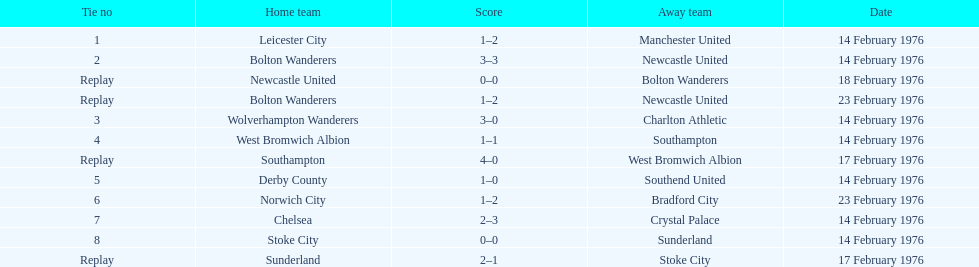How do southampton's and sunderland's scores differ? 2 goals. Parse the table in full. {'header': ['Tie no', 'Home team', 'Score', 'Away team', 'Date'], 'rows': [['1', 'Leicester City', '1–2', 'Manchester United', '14 February 1976'], ['2', 'Bolton Wanderers', '3–3', 'Newcastle United', '14 February 1976'], ['Replay', 'Newcastle United', '0–0', 'Bolton Wanderers', '18 February 1976'], ['Replay', 'Bolton Wanderers', '1–2', 'Newcastle United', '23 February 1976'], ['3', 'Wolverhampton Wanderers', '3–0', 'Charlton Athletic', '14 February 1976'], ['4', 'West Bromwich Albion', '1–1', 'Southampton', '14 February 1976'], ['Replay', 'Southampton', '4–0', 'West Bromwich Albion', '17 February 1976'], ['5', 'Derby County', '1–0', 'Southend United', '14 February 1976'], ['6', 'Norwich City', '1–2', 'Bradford City', '23 February 1976'], ['7', 'Chelsea', '2–3', 'Crystal Palace', '14 February 1976'], ['8', 'Stoke City', '0–0', 'Sunderland', '14 February 1976'], ['Replay', 'Sunderland', '2–1', 'Stoke City', '17 February 1976']]} 